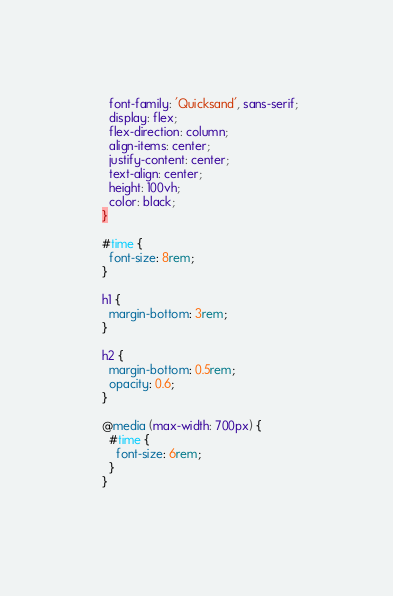Convert code to text. <code><loc_0><loc_0><loc_500><loc_500><_CSS_>    font-family: 'Quicksand', sans-serif;
    display: flex;
    flex-direction: column;
    align-items: center;
    justify-content: center;
    text-align: center;
    height: 100vh;
    color: black;
  }
  
  #time {
    font-size: 8rem;
  }
  
  h1 {
    margin-bottom: 3rem;
  }
  
  h2 {
    margin-bottom: 0.5rem;
    opacity: 0.6;
  }
  
  @media (max-width: 700px) {
    #time {
      font-size: 6rem;
    }
  }
  </code> 